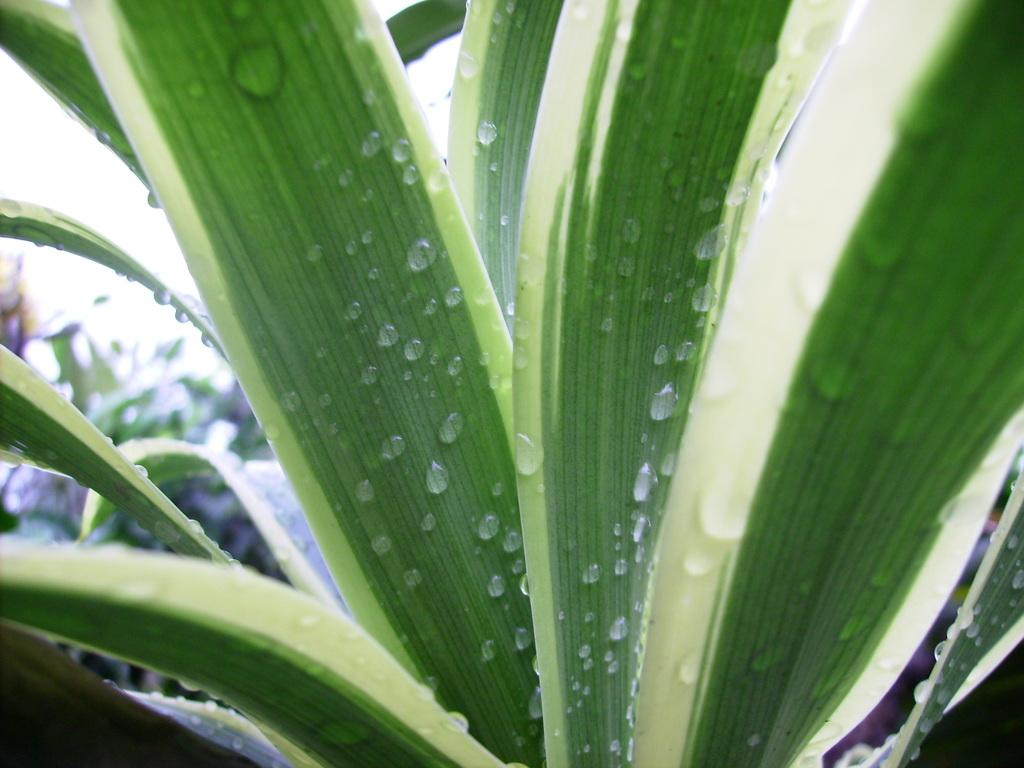What is present in the image? There is a plant in the image. Can you describe the plant's appearance? The plant has leaves. What can be observed on the leaves of the plant? There are droplets of water on the leaves. What type of wool is being used to create the plant's leaves in the image? There is no wool present in the image; the plant's leaves are natural and not made of wool. 